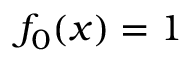<formula> <loc_0><loc_0><loc_500><loc_500>f _ { 0 } ( x ) = 1</formula> 